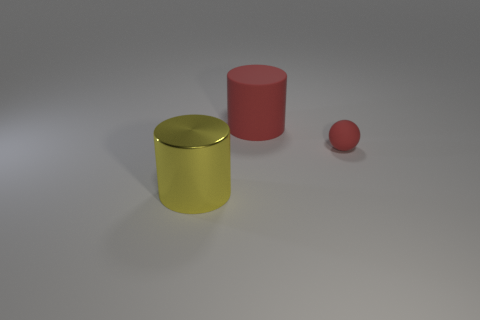Add 1 matte objects. How many objects exist? 4 Subtract all spheres. How many objects are left? 2 Add 1 large rubber things. How many large rubber things are left? 2 Add 2 big red rubber spheres. How many big red rubber spheres exist? 2 Subtract 1 red cylinders. How many objects are left? 2 Subtract all large blue rubber cylinders. Subtract all small red things. How many objects are left? 2 